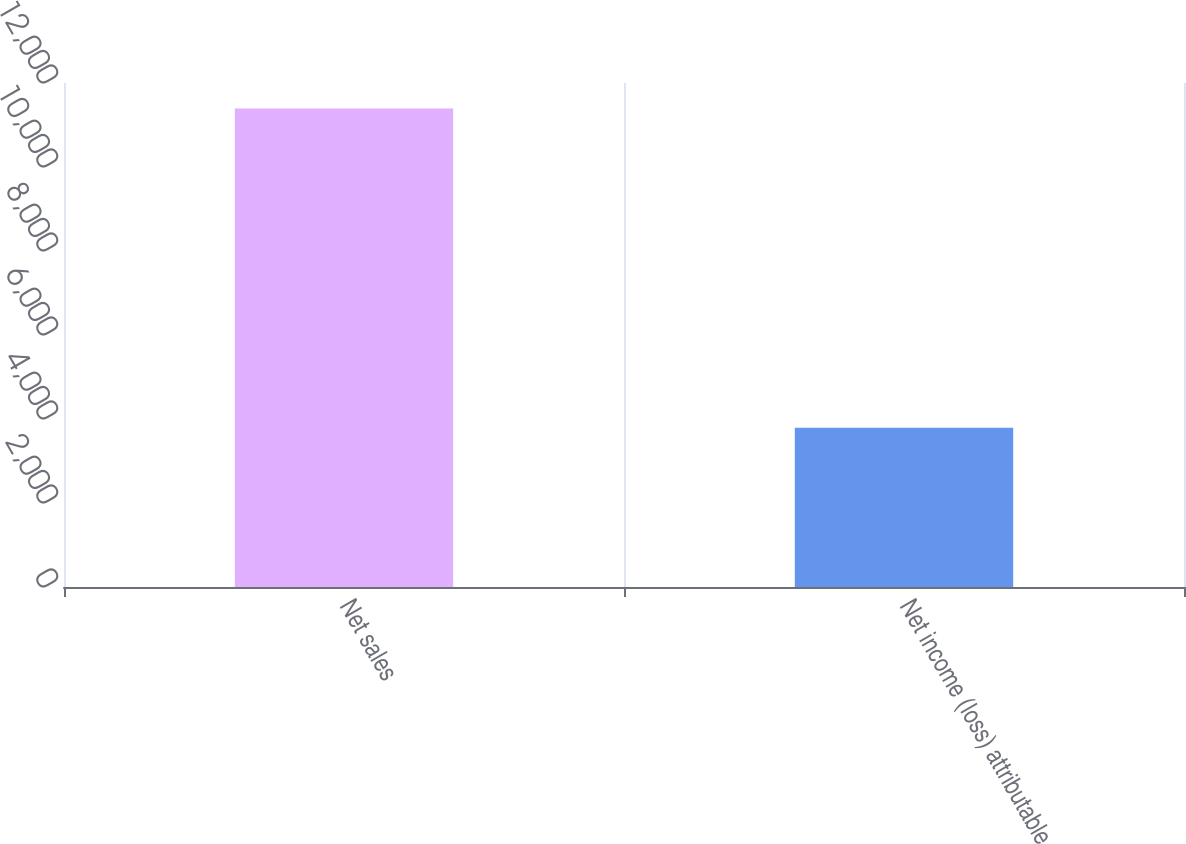Convert chart. <chart><loc_0><loc_0><loc_500><loc_500><bar_chart><fcel>Net sales<fcel>Net income (loss) attributable<nl><fcel>11393<fcel>3790<nl></chart> 